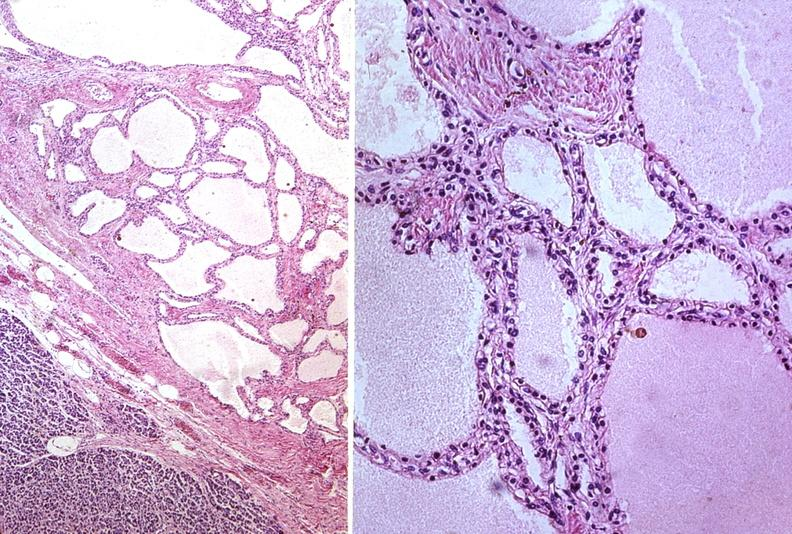what is present?
Answer the question using a single word or phrase. Pancreas 